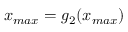<formula> <loc_0><loc_0><loc_500><loc_500>x _ { \max } = g _ { 2 } ( x _ { \max } )</formula> 